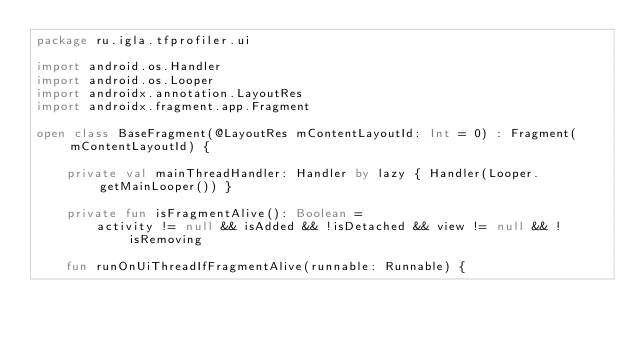Convert code to text. <code><loc_0><loc_0><loc_500><loc_500><_Kotlin_>package ru.igla.tfprofiler.ui

import android.os.Handler
import android.os.Looper
import androidx.annotation.LayoutRes
import androidx.fragment.app.Fragment

open class BaseFragment(@LayoutRes mContentLayoutId: Int = 0) : Fragment(mContentLayoutId) {

    private val mainThreadHandler: Handler by lazy { Handler(Looper.getMainLooper()) }

    private fun isFragmentAlive(): Boolean =
        activity != null && isAdded && !isDetached && view != null && !isRemoving

    fun runOnUiThreadIfFragmentAlive(runnable: Runnable) {</code> 